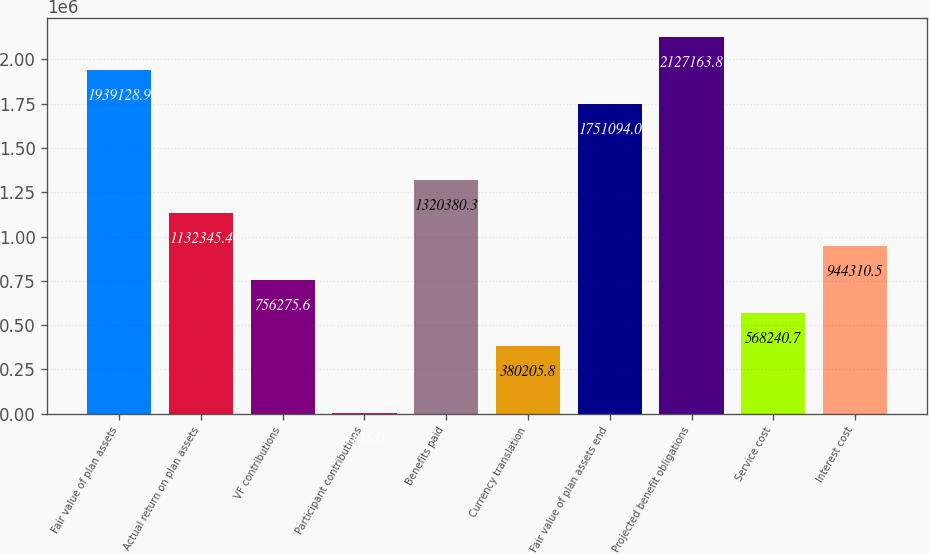<chart> <loc_0><loc_0><loc_500><loc_500><bar_chart><fcel>Fair value of plan assets<fcel>Actual return on plan assets<fcel>VF contributions<fcel>Participant contributions<fcel>Benefits paid<fcel>Currency translation<fcel>Fair value of plan assets end<fcel>Projected benefit obligations<fcel>Service cost<fcel>Interest cost<nl><fcel>1.93913e+06<fcel>1.13235e+06<fcel>756276<fcel>4136<fcel>1.32038e+06<fcel>380206<fcel>1.75109e+06<fcel>2.12716e+06<fcel>568241<fcel>944310<nl></chart> 